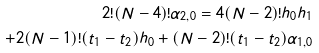Convert formula to latex. <formula><loc_0><loc_0><loc_500><loc_500>2 ! ( N - 4 ) ! \alpha _ { 2 , 0 } = 4 ( N - 2 ) ! h _ { 0 } h _ { 1 } \\ + 2 ( N - 1 ) ! ( t _ { 1 } - t _ { 2 } ) h _ { 0 } + ( N - 2 ) ! ( t _ { 1 } - t _ { 2 } ) \alpha _ { 1 , 0 }</formula> 